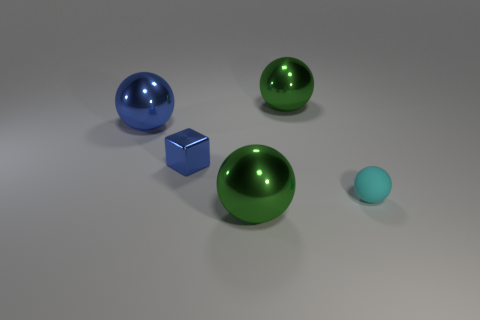Can you tell me what colors are the objects in the image? Certainly! In the image, there are objects with several distinct colors: one object is blue, another is green, there's a tiny ball that is light blue, and finally, there's a cube that appears to be silver or gray. 